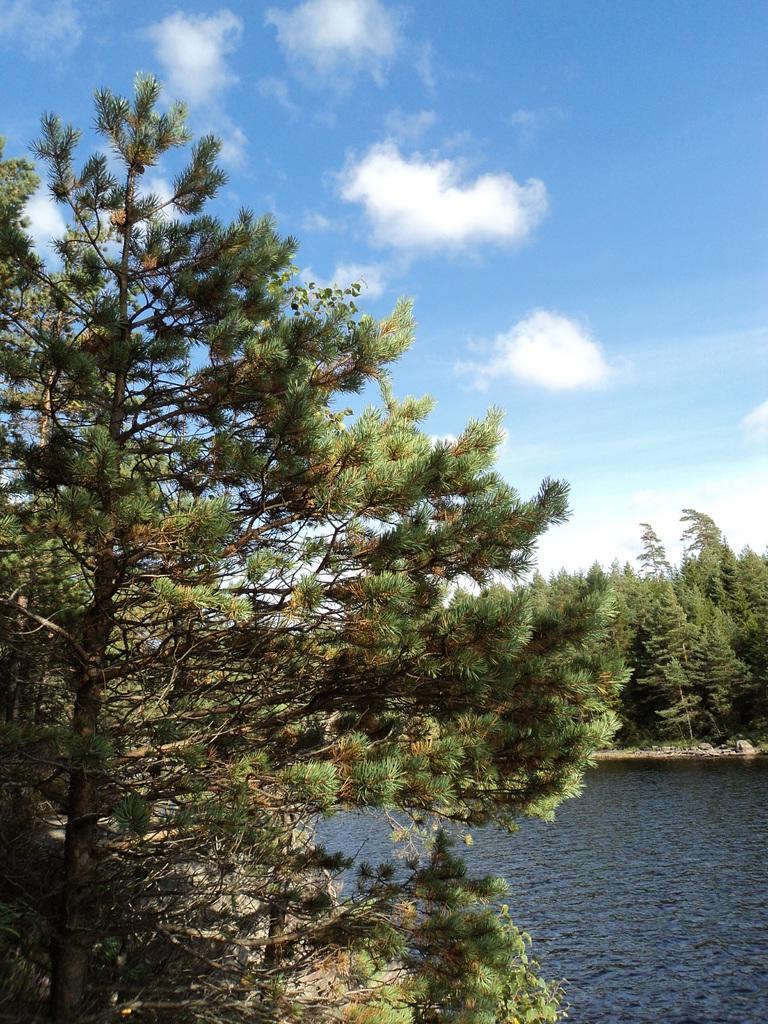Could you give a brief overview of what you see in this image? In this image, we can see trees. At the bottom, there is water and at the top, there are clouds in the sky. 